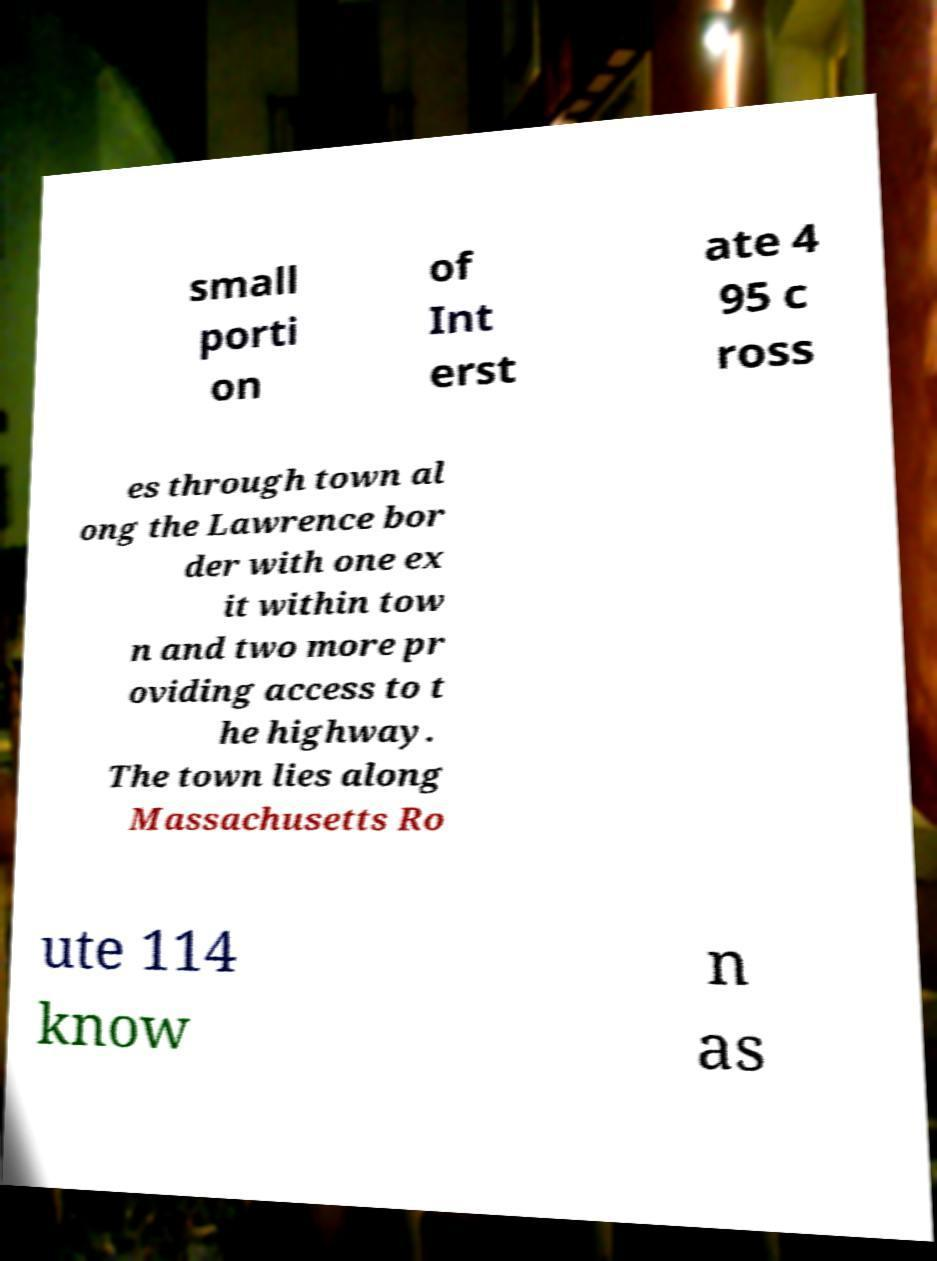For documentation purposes, I need the text within this image transcribed. Could you provide that? small porti on of Int erst ate 4 95 c ross es through town al ong the Lawrence bor der with one ex it within tow n and two more pr oviding access to t he highway. The town lies along Massachusetts Ro ute 114 know n as 